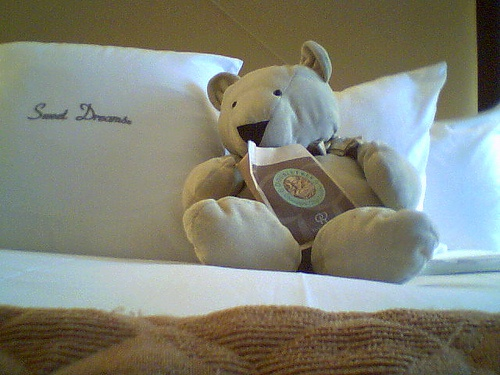Describe the objects in this image and their specific colors. I can see bed in darkgreen, darkgray, lightblue, lightgray, and gray tones, teddy bear in darkgreen, gray, darkgray, and tan tones, bed in darkgreen, olive, gray, maroon, and black tones, and book in darkgreen, gray, darkgray, and olive tones in this image. 